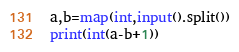<code> <loc_0><loc_0><loc_500><loc_500><_Python_>a,b=map(int,input().split())
print(int(a-b+1))</code> 